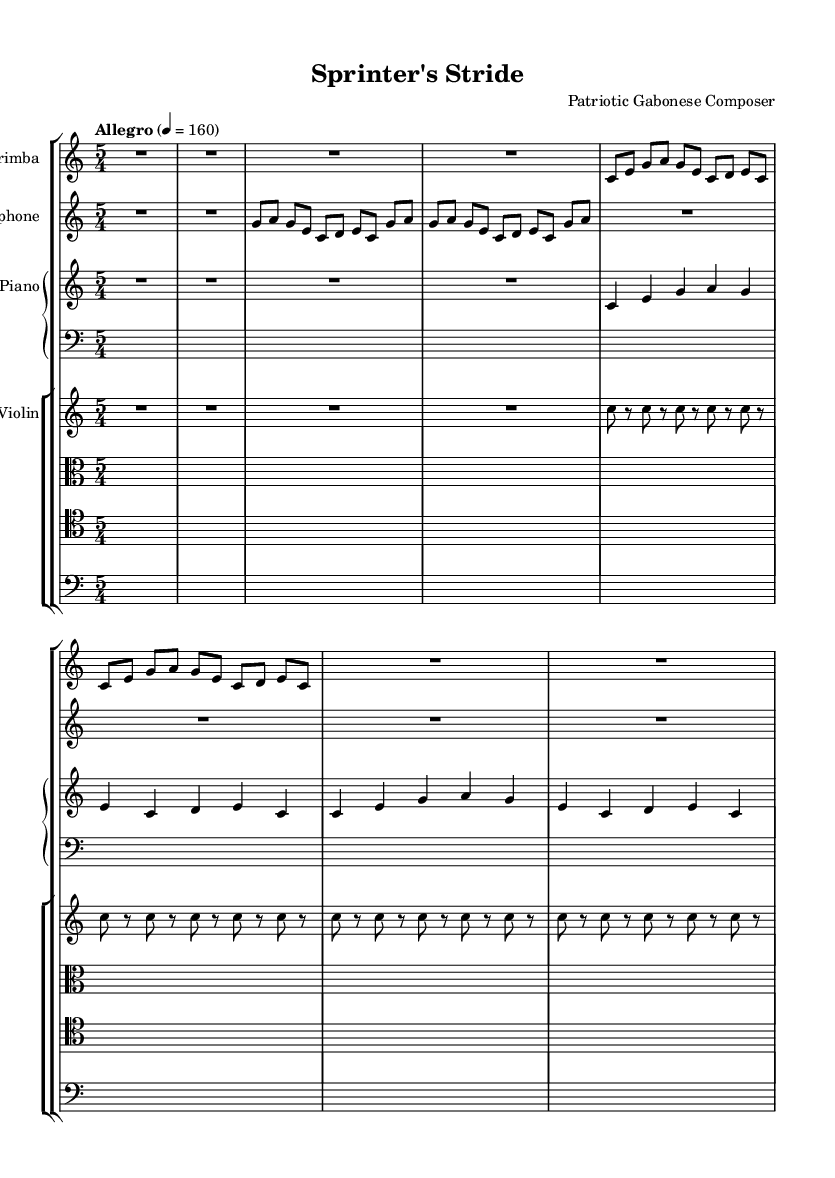What is the key signature of this music? The key signature is C major, which is indicated at the beginning of the score. C major has no sharps or flats.
Answer: C major What is the time signature of this composition? The time signature shown in the score is 5/4, which can be found at the start of the global section. It indicates five beats per measure with a quarter note receiving one beat.
Answer: 5/4 What is the tempo marking for this piece? The tempo marking "Allegro" can be found at the beginning of the score, which indicates a fast and lively pace. The metronome marking of 160 beats per minute reinforces this tempo.
Answer: Allegro, 160 How many measures does the marimba part contain? Counting the measures in the marimba part, there are a total of 6 measures indicated by the notation. This includes both filled measures and rests.
Answer: 6 Which instrument plays the repeated note pattern? The violin part features repeated notes, specifically the note 'c' played several times throughout, reflecting a minimalist style that emphasizes rhythmic precision, which relates to athletic movements.
Answer: Violin How is rhythmic precision represented in the musical score? The piece uses a repetitive structure, particularly in the marimba and vibraphone sections, creating a sense of rhythmic precision that parallels athletic movements. This is an essential characteristic of minimalist compositions.
Answer: Repetitive structure 